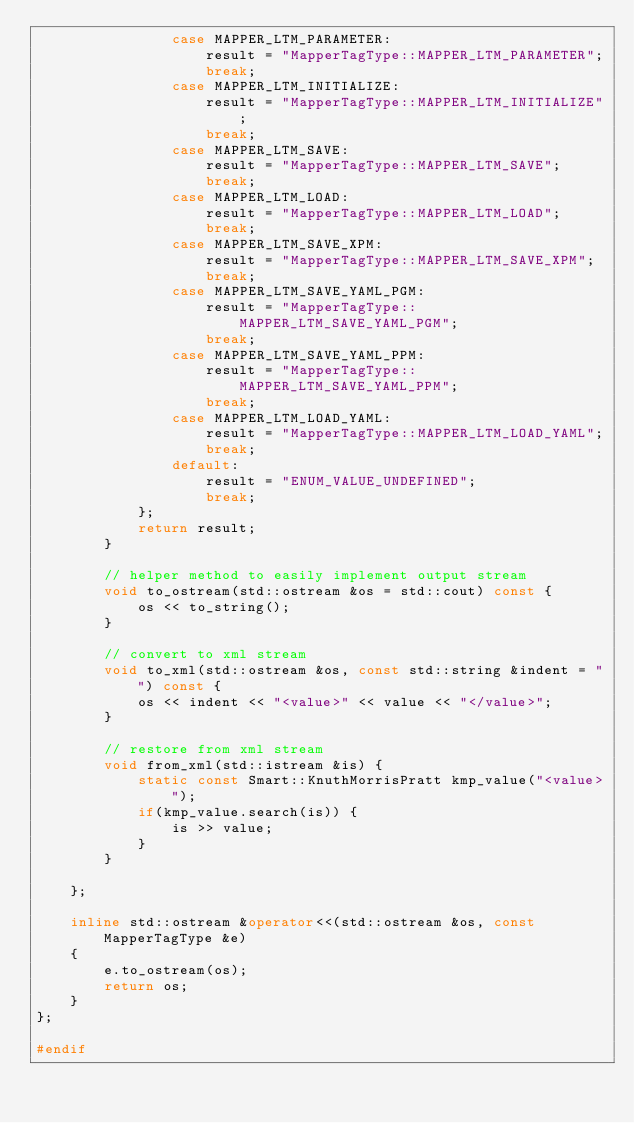<code> <loc_0><loc_0><loc_500><loc_500><_C++_>				case MAPPER_LTM_PARAMETER:
					result = "MapperTagType::MAPPER_LTM_PARAMETER";
					break;
				case MAPPER_LTM_INITIALIZE:
					result = "MapperTagType::MAPPER_LTM_INITIALIZE";
					break;
				case MAPPER_LTM_SAVE:
					result = "MapperTagType::MAPPER_LTM_SAVE";
					break;
				case MAPPER_LTM_LOAD:
					result = "MapperTagType::MAPPER_LTM_LOAD";
					break;
				case MAPPER_LTM_SAVE_XPM:
					result = "MapperTagType::MAPPER_LTM_SAVE_XPM";
					break;
				case MAPPER_LTM_SAVE_YAML_PGM:
					result = "MapperTagType::MAPPER_LTM_SAVE_YAML_PGM";
					break;
				case MAPPER_LTM_SAVE_YAML_PPM:
					result = "MapperTagType::MAPPER_LTM_SAVE_YAML_PPM";
					break;
				case MAPPER_LTM_LOAD_YAML:
					result = "MapperTagType::MAPPER_LTM_LOAD_YAML";
					break;
				default:
					result = "ENUM_VALUE_UNDEFINED";
					break;
			};
			return result;
		}
		
		// helper method to easily implement output stream
		void to_ostream(std::ostream &os = std::cout) const {
			os << to_string();
		}
		
		// convert to xml stream
		void to_xml(std::ostream &os, const std::string &indent = "") const {
			os << indent << "<value>" << value << "</value>";
		}
		
		// restore from xml stream
		void from_xml(std::istream &is) {
			static const Smart::KnuthMorrisPratt kmp_value("<value>");
			if(kmp_value.search(is)) {
				is >> value;
			}
		}
	
	};
	
	inline std::ostream &operator<<(std::ostream &os, const MapperTagType &e)
	{
		e.to_ostream(os);
		return os;
	}
};

#endif
</code> 